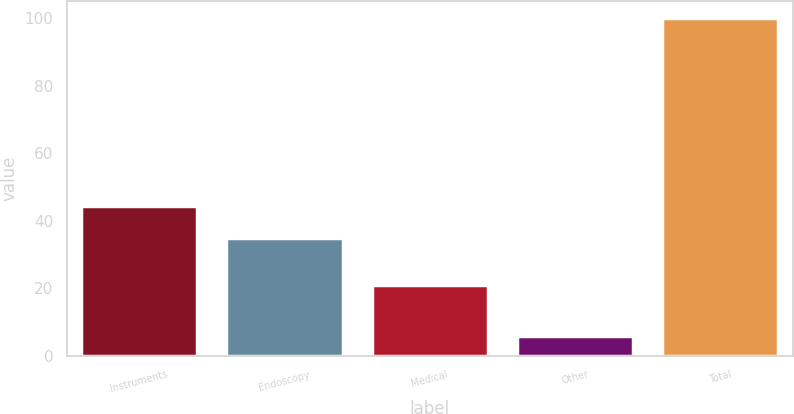<chart> <loc_0><loc_0><loc_500><loc_500><bar_chart><fcel>Instruments<fcel>Endoscopy<fcel>Medical<fcel>Other<fcel>Total<nl><fcel>44.4<fcel>35<fcel>21<fcel>6<fcel>100<nl></chart> 